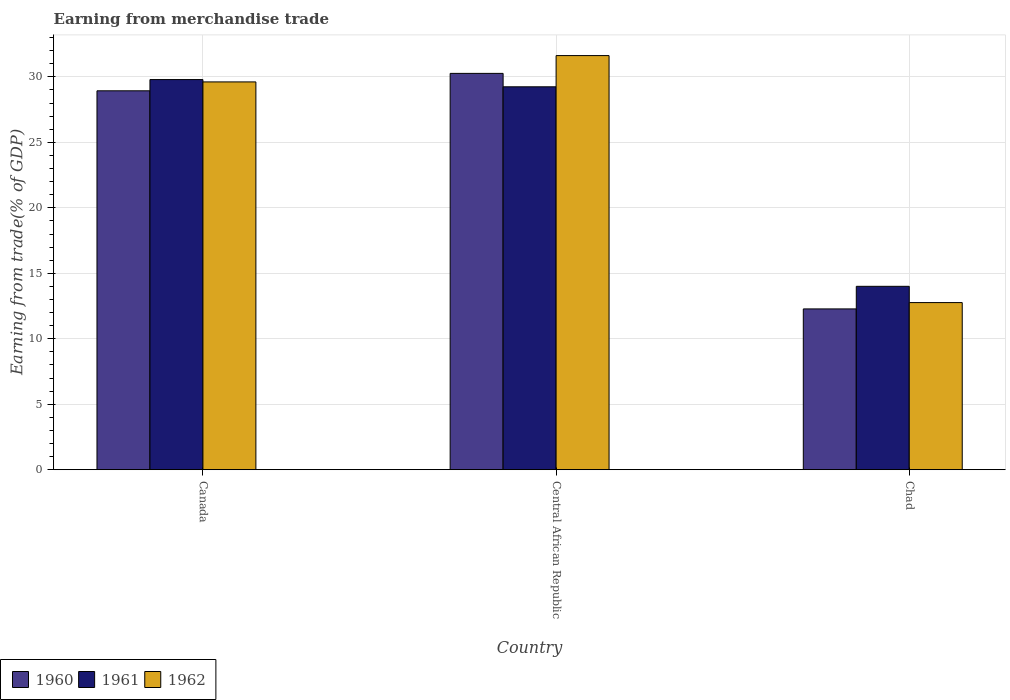Are the number of bars per tick equal to the number of legend labels?
Ensure brevity in your answer.  Yes. How many bars are there on the 3rd tick from the left?
Your response must be concise. 3. In how many cases, is the number of bars for a given country not equal to the number of legend labels?
Make the answer very short. 0. What is the earnings from trade in 1961 in Canada?
Keep it short and to the point. 29.8. Across all countries, what is the maximum earnings from trade in 1962?
Offer a terse response. 31.63. Across all countries, what is the minimum earnings from trade in 1960?
Provide a short and direct response. 12.28. In which country was the earnings from trade in 1962 maximum?
Ensure brevity in your answer.  Central African Republic. In which country was the earnings from trade in 1962 minimum?
Keep it short and to the point. Chad. What is the total earnings from trade in 1960 in the graph?
Your answer should be compact. 71.49. What is the difference between the earnings from trade in 1960 in Canada and that in Central African Republic?
Offer a very short reply. -1.33. What is the difference between the earnings from trade in 1961 in Central African Republic and the earnings from trade in 1960 in Canada?
Make the answer very short. 0.31. What is the average earnings from trade in 1962 per country?
Offer a very short reply. 24.67. What is the difference between the earnings from trade of/in 1961 and earnings from trade of/in 1962 in Chad?
Your answer should be compact. 1.24. What is the ratio of the earnings from trade in 1962 in Central African Republic to that in Chad?
Make the answer very short. 2.48. Is the difference between the earnings from trade in 1961 in Canada and Central African Republic greater than the difference between the earnings from trade in 1962 in Canada and Central African Republic?
Offer a very short reply. Yes. What is the difference between the highest and the second highest earnings from trade in 1962?
Keep it short and to the point. -16.85. What is the difference between the highest and the lowest earnings from trade in 1962?
Offer a very short reply. 18.86. In how many countries, is the earnings from trade in 1960 greater than the average earnings from trade in 1960 taken over all countries?
Ensure brevity in your answer.  2. Is the sum of the earnings from trade in 1962 in Canada and Central African Republic greater than the maximum earnings from trade in 1960 across all countries?
Keep it short and to the point. Yes. What does the 1st bar from the left in Chad represents?
Give a very brief answer. 1960. What does the 2nd bar from the right in Chad represents?
Keep it short and to the point. 1961. How many countries are there in the graph?
Make the answer very short. 3. What is the difference between two consecutive major ticks on the Y-axis?
Offer a terse response. 5. Does the graph contain any zero values?
Keep it short and to the point. No. Does the graph contain grids?
Your answer should be compact. Yes. Where does the legend appear in the graph?
Offer a very short reply. Bottom left. How many legend labels are there?
Keep it short and to the point. 3. How are the legend labels stacked?
Give a very brief answer. Horizontal. What is the title of the graph?
Your answer should be compact. Earning from merchandise trade. Does "2008" appear as one of the legend labels in the graph?
Offer a very short reply. No. What is the label or title of the Y-axis?
Provide a succinct answer. Earning from trade(% of GDP). What is the Earning from trade(% of GDP) in 1960 in Canada?
Make the answer very short. 28.94. What is the Earning from trade(% of GDP) in 1961 in Canada?
Ensure brevity in your answer.  29.8. What is the Earning from trade(% of GDP) of 1962 in Canada?
Offer a very short reply. 29.62. What is the Earning from trade(% of GDP) in 1960 in Central African Republic?
Ensure brevity in your answer.  30.27. What is the Earning from trade(% of GDP) in 1961 in Central African Republic?
Your response must be concise. 29.24. What is the Earning from trade(% of GDP) in 1962 in Central African Republic?
Provide a short and direct response. 31.63. What is the Earning from trade(% of GDP) of 1960 in Chad?
Your answer should be compact. 12.28. What is the Earning from trade(% of GDP) in 1961 in Chad?
Give a very brief answer. 14. What is the Earning from trade(% of GDP) of 1962 in Chad?
Give a very brief answer. 12.76. Across all countries, what is the maximum Earning from trade(% of GDP) of 1960?
Offer a terse response. 30.27. Across all countries, what is the maximum Earning from trade(% of GDP) of 1961?
Give a very brief answer. 29.8. Across all countries, what is the maximum Earning from trade(% of GDP) of 1962?
Offer a very short reply. 31.63. Across all countries, what is the minimum Earning from trade(% of GDP) in 1960?
Your response must be concise. 12.28. Across all countries, what is the minimum Earning from trade(% of GDP) of 1961?
Your response must be concise. 14. Across all countries, what is the minimum Earning from trade(% of GDP) in 1962?
Offer a terse response. 12.76. What is the total Earning from trade(% of GDP) in 1960 in the graph?
Give a very brief answer. 71.49. What is the total Earning from trade(% of GDP) in 1961 in the graph?
Make the answer very short. 73.05. What is the total Earning from trade(% of GDP) in 1962 in the graph?
Offer a very short reply. 74.01. What is the difference between the Earning from trade(% of GDP) in 1960 in Canada and that in Central African Republic?
Offer a very short reply. -1.33. What is the difference between the Earning from trade(% of GDP) in 1961 in Canada and that in Central African Republic?
Your answer should be compact. 0.55. What is the difference between the Earning from trade(% of GDP) in 1962 in Canada and that in Central African Republic?
Ensure brevity in your answer.  -2.01. What is the difference between the Earning from trade(% of GDP) of 1960 in Canada and that in Chad?
Make the answer very short. 16.66. What is the difference between the Earning from trade(% of GDP) of 1961 in Canada and that in Chad?
Your response must be concise. 15.79. What is the difference between the Earning from trade(% of GDP) of 1962 in Canada and that in Chad?
Provide a succinct answer. 16.85. What is the difference between the Earning from trade(% of GDP) in 1960 in Central African Republic and that in Chad?
Provide a short and direct response. 17.99. What is the difference between the Earning from trade(% of GDP) in 1961 in Central African Republic and that in Chad?
Keep it short and to the point. 15.24. What is the difference between the Earning from trade(% of GDP) of 1962 in Central African Republic and that in Chad?
Ensure brevity in your answer.  18.86. What is the difference between the Earning from trade(% of GDP) in 1960 in Canada and the Earning from trade(% of GDP) in 1961 in Central African Republic?
Give a very brief answer. -0.31. What is the difference between the Earning from trade(% of GDP) in 1960 in Canada and the Earning from trade(% of GDP) in 1962 in Central African Republic?
Your response must be concise. -2.69. What is the difference between the Earning from trade(% of GDP) in 1961 in Canada and the Earning from trade(% of GDP) in 1962 in Central African Republic?
Keep it short and to the point. -1.83. What is the difference between the Earning from trade(% of GDP) of 1960 in Canada and the Earning from trade(% of GDP) of 1961 in Chad?
Your answer should be very brief. 14.93. What is the difference between the Earning from trade(% of GDP) in 1960 in Canada and the Earning from trade(% of GDP) in 1962 in Chad?
Your response must be concise. 16.17. What is the difference between the Earning from trade(% of GDP) of 1961 in Canada and the Earning from trade(% of GDP) of 1962 in Chad?
Provide a succinct answer. 17.03. What is the difference between the Earning from trade(% of GDP) of 1960 in Central African Republic and the Earning from trade(% of GDP) of 1961 in Chad?
Provide a short and direct response. 16.26. What is the difference between the Earning from trade(% of GDP) in 1960 in Central African Republic and the Earning from trade(% of GDP) in 1962 in Chad?
Your response must be concise. 17.5. What is the difference between the Earning from trade(% of GDP) of 1961 in Central African Republic and the Earning from trade(% of GDP) of 1962 in Chad?
Your answer should be very brief. 16.48. What is the average Earning from trade(% of GDP) of 1960 per country?
Your answer should be very brief. 23.83. What is the average Earning from trade(% of GDP) of 1961 per country?
Your answer should be compact. 24.35. What is the average Earning from trade(% of GDP) of 1962 per country?
Your answer should be very brief. 24.67. What is the difference between the Earning from trade(% of GDP) in 1960 and Earning from trade(% of GDP) in 1961 in Canada?
Your answer should be very brief. -0.86. What is the difference between the Earning from trade(% of GDP) of 1960 and Earning from trade(% of GDP) of 1962 in Canada?
Keep it short and to the point. -0.68. What is the difference between the Earning from trade(% of GDP) in 1961 and Earning from trade(% of GDP) in 1962 in Canada?
Provide a short and direct response. 0.18. What is the difference between the Earning from trade(% of GDP) in 1960 and Earning from trade(% of GDP) in 1961 in Central African Republic?
Keep it short and to the point. 1.02. What is the difference between the Earning from trade(% of GDP) of 1960 and Earning from trade(% of GDP) of 1962 in Central African Republic?
Provide a short and direct response. -1.36. What is the difference between the Earning from trade(% of GDP) in 1961 and Earning from trade(% of GDP) in 1962 in Central African Republic?
Your response must be concise. -2.38. What is the difference between the Earning from trade(% of GDP) in 1960 and Earning from trade(% of GDP) in 1961 in Chad?
Ensure brevity in your answer.  -1.72. What is the difference between the Earning from trade(% of GDP) in 1960 and Earning from trade(% of GDP) in 1962 in Chad?
Keep it short and to the point. -0.48. What is the difference between the Earning from trade(% of GDP) of 1961 and Earning from trade(% of GDP) of 1962 in Chad?
Provide a short and direct response. 1.24. What is the ratio of the Earning from trade(% of GDP) of 1960 in Canada to that in Central African Republic?
Keep it short and to the point. 0.96. What is the ratio of the Earning from trade(% of GDP) in 1961 in Canada to that in Central African Republic?
Your answer should be very brief. 1.02. What is the ratio of the Earning from trade(% of GDP) in 1962 in Canada to that in Central African Republic?
Give a very brief answer. 0.94. What is the ratio of the Earning from trade(% of GDP) in 1960 in Canada to that in Chad?
Give a very brief answer. 2.36. What is the ratio of the Earning from trade(% of GDP) in 1961 in Canada to that in Chad?
Make the answer very short. 2.13. What is the ratio of the Earning from trade(% of GDP) in 1962 in Canada to that in Chad?
Keep it short and to the point. 2.32. What is the ratio of the Earning from trade(% of GDP) of 1960 in Central African Republic to that in Chad?
Offer a terse response. 2.46. What is the ratio of the Earning from trade(% of GDP) of 1961 in Central African Republic to that in Chad?
Provide a short and direct response. 2.09. What is the ratio of the Earning from trade(% of GDP) in 1962 in Central African Republic to that in Chad?
Your response must be concise. 2.48. What is the difference between the highest and the second highest Earning from trade(% of GDP) of 1960?
Keep it short and to the point. 1.33. What is the difference between the highest and the second highest Earning from trade(% of GDP) of 1961?
Offer a terse response. 0.55. What is the difference between the highest and the second highest Earning from trade(% of GDP) of 1962?
Offer a terse response. 2.01. What is the difference between the highest and the lowest Earning from trade(% of GDP) in 1960?
Provide a succinct answer. 17.99. What is the difference between the highest and the lowest Earning from trade(% of GDP) of 1961?
Provide a short and direct response. 15.79. What is the difference between the highest and the lowest Earning from trade(% of GDP) in 1962?
Make the answer very short. 18.86. 